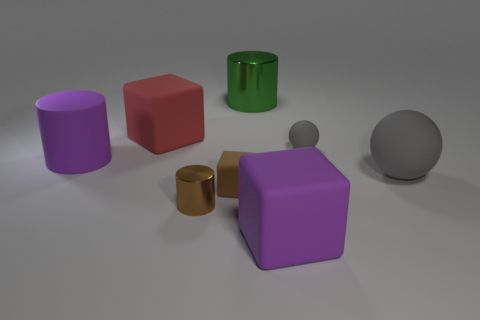Subtract all red blocks. How many blocks are left? 2 Subtract all big purple cylinders. How many cylinders are left? 2 Subtract all spheres. How many objects are left? 6 Add 1 tiny blue things. How many objects exist? 9 Subtract 1 spheres. How many spheres are left? 1 Add 7 big gray objects. How many big gray objects are left? 8 Add 7 small red matte objects. How many small red matte objects exist? 7 Subtract 0 green blocks. How many objects are left? 8 Subtract all red cubes. Subtract all blue spheres. How many cubes are left? 2 Subtract all purple spheres. How many green cylinders are left? 1 